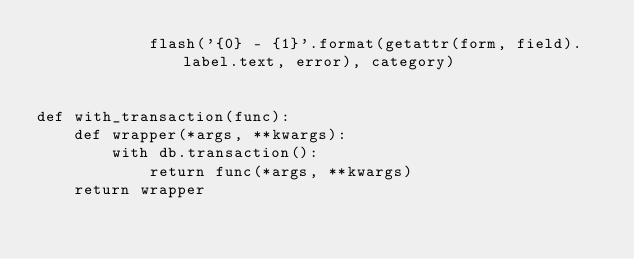<code> <loc_0><loc_0><loc_500><loc_500><_Python_>            flash('{0} - {1}'.format(getattr(form, field).label.text, error), category)


def with_transaction(func):
    def wrapper(*args, **kwargs):
        with db.transaction():
            return func(*args, **kwargs)
    return wrapper
</code> 